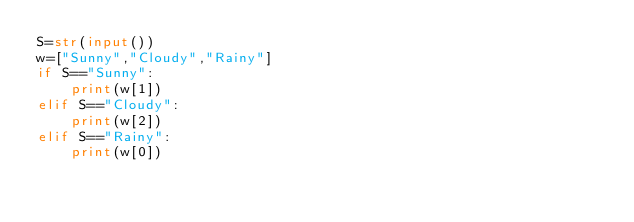<code> <loc_0><loc_0><loc_500><loc_500><_Python_>S=str(input())
w=["Sunny","Cloudy","Rainy"]
if S=="Sunny":
	print(w[1])
elif S=="Cloudy":
    print(w[2])
elif S=="Rainy":
    print(w[0])</code> 